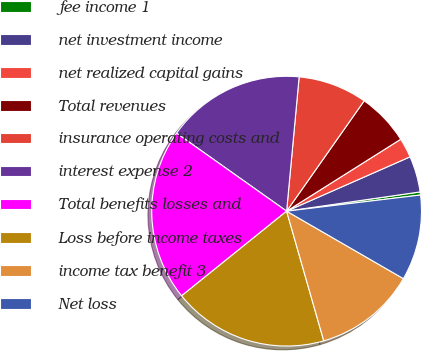<chart> <loc_0><loc_0><loc_500><loc_500><pie_chart><fcel>fee income 1<fcel>net investment income<fcel>net realized capital gains<fcel>Total revenues<fcel>insurance operating costs and<fcel>interest expense 2<fcel>Total benefits losses and<fcel>Loss before income taxes<fcel>income tax benefit 3<fcel>Net loss<nl><fcel>0.37%<fcel>4.32%<fcel>2.35%<fcel>6.3%<fcel>8.27%<fcel>16.67%<fcel>20.61%<fcel>18.64%<fcel>12.22%<fcel>10.25%<nl></chart> 